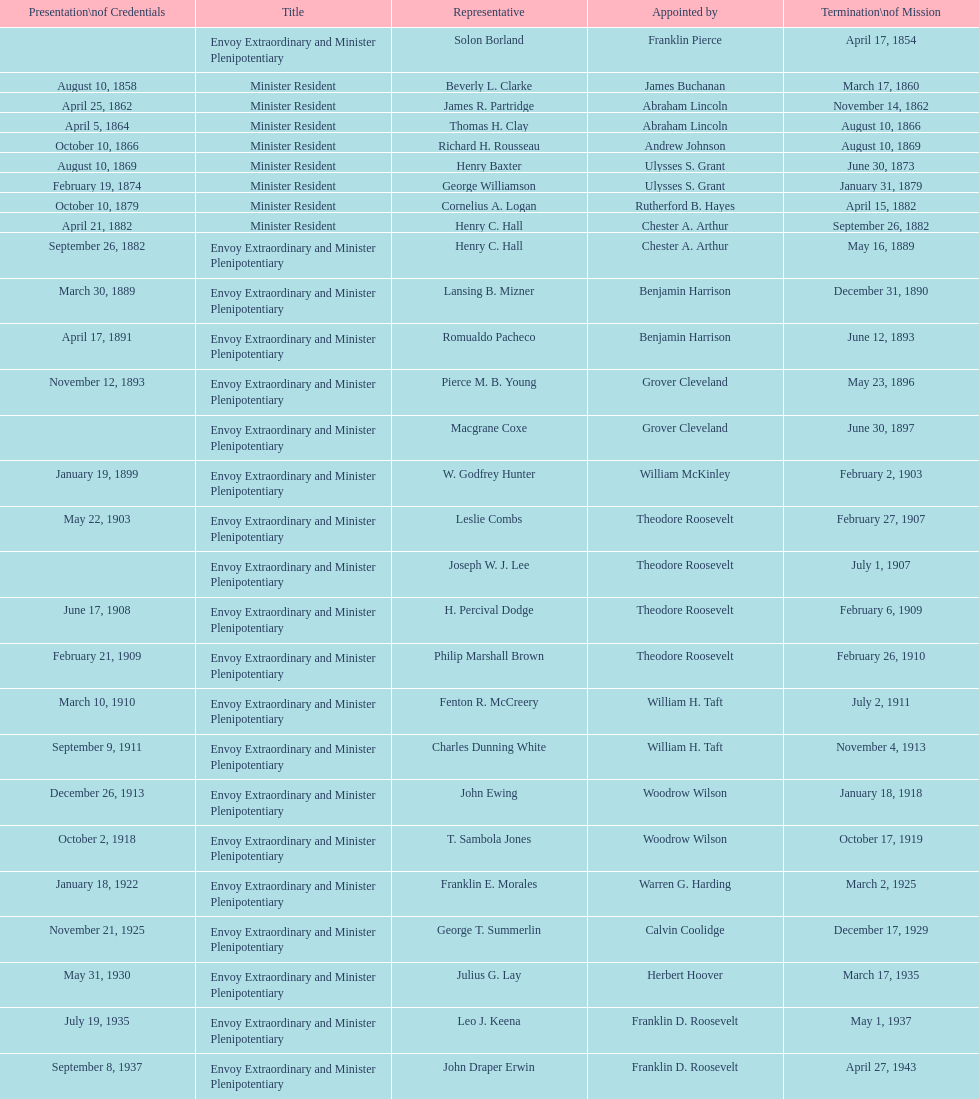Which minister resident had the shortest appointment? Henry C. Hall. 